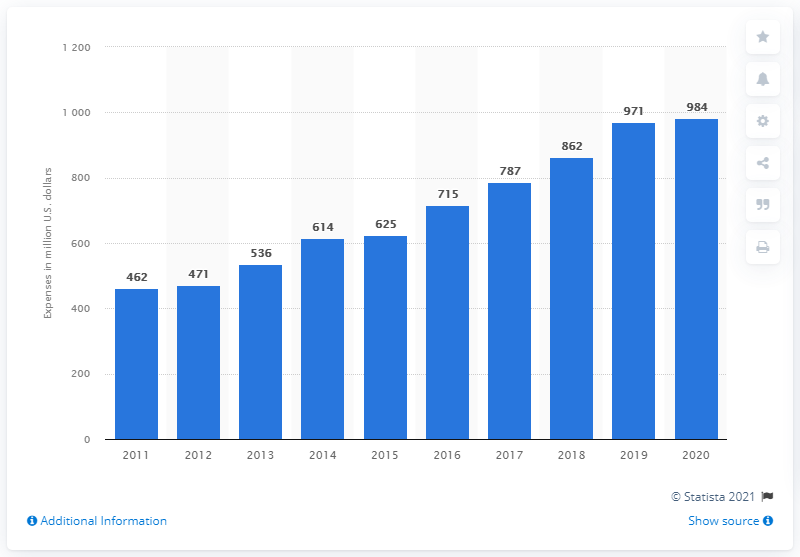How much money did Stryker spend in research, development and engineering in 2020? In 2020, Stryker Corporation invested a total of 984 million U.S. dollars in research, development, and engineering, as depicted in the provided bar chart, which shows a consistent increase in investment over the years. 